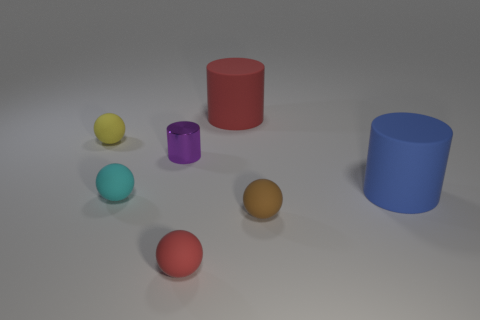What number of other objects are there of the same material as the yellow thing?
Your answer should be very brief. 5. What is the size of the red matte object that is behind the blue rubber cylinder?
Your answer should be very brief. Large. What shape is the large blue object that is made of the same material as the brown object?
Ensure brevity in your answer.  Cylinder. Are the small purple thing and the red thing in front of the yellow sphere made of the same material?
Make the answer very short. No. There is a large object that is behind the small yellow object; does it have the same shape as the small brown rubber thing?
Ensure brevity in your answer.  No. There is another big thing that is the same shape as the blue object; what is it made of?
Offer a very short reply. Rubber. There is a small red rubber thing; does it have the same shape as the thing right of the brown matte ball?
Make the answer very short. No. The small ball that is on the left side of the purple cylinder and in front of the large blue object is what color?
Ensure brevity in your answer.  Cyan. Are there any small yellow matte spheres?
Ensure brevity in your answer.  Yes. Are there the same number of small cyan things in front of the red rubber ball and small blue matte things?
Ensure brevity in your answer.  Yes. 